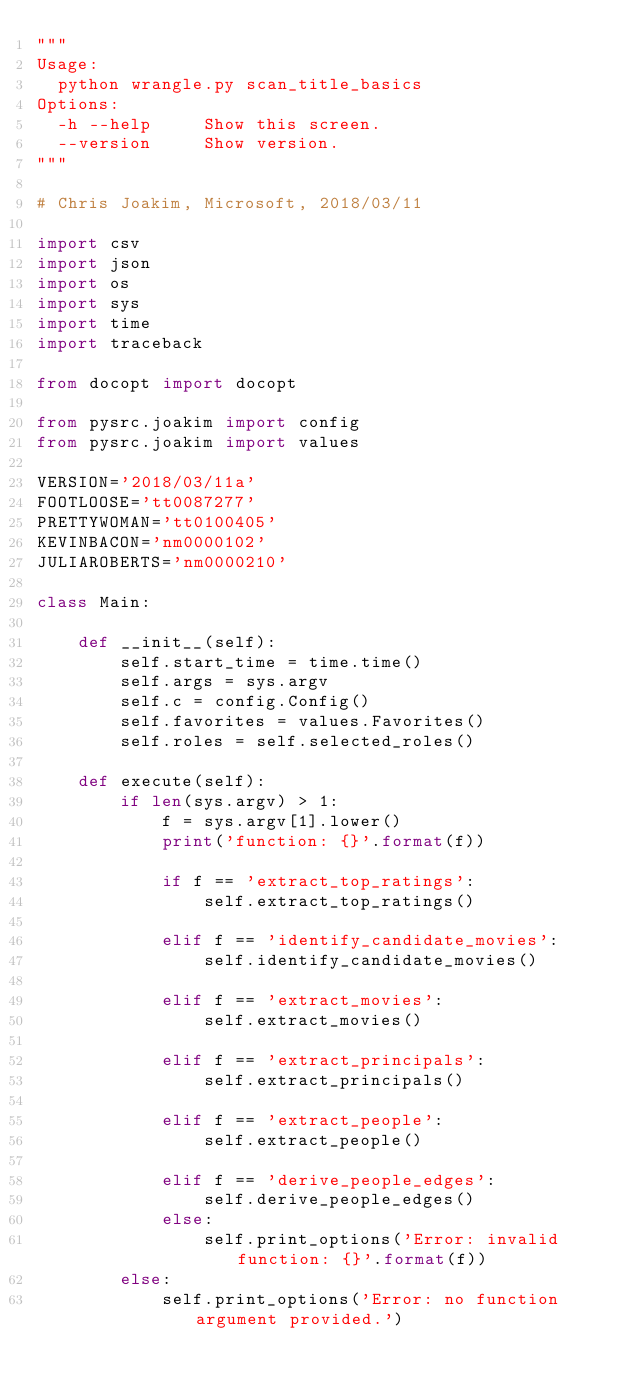Convert code to text. <code><loc_0><loc_0><loc_500><loc_500><_Python_>"""
Usage:
  python wrangle.py scan_title_basics
Options:
  -h --help     Show this screen.
  --version     Show version.
"""

# Chris Joakim, Microsoft, 2018/03/11

import csv
import json
import os
import sys
import time
import traceback

from docopt import docopt

from pysrc.joakim import config
from pysrc.joakim import values

VERSION='2018/03/11a'
FOOTLOOSE='tt0087277'
PRETTYWOMAN='tt0100405'
KEVINBACON='nm0000102'
JULIAROBERTS='nm0000210'

class Main:

    def __init__(self):
        self.start_time = time.time()
        self.args = sys.argv
        self.c = config.Config()
        self.favorites = values.Favorites()
        self.roles = self.selected_roles()

    def execute(self):
        if len(sys.argv) > 1:
            f = sys.argv[1].lower()
            print('function: {}'.format(f))

            if f == 'extract_top_ratings':
                self.extract_top_ratings()

            elif f == 'identify_candidate_movies':
                self.identify_candidate_movies()

            elif f == 'extract_movies':
                self.extract_movies()

            elif f == 'extract_principals':
                self.extract_principals()

            elif f == 'extract_people':
                self.extract_people()

            elif f == 'derive_people_edges':
                self.derive_people_edges()
            else:
                self.print_options('Error: invalid function: {}'.format(f))
        else:
            self.print_options('Error: no function argument provided.')
</code> 